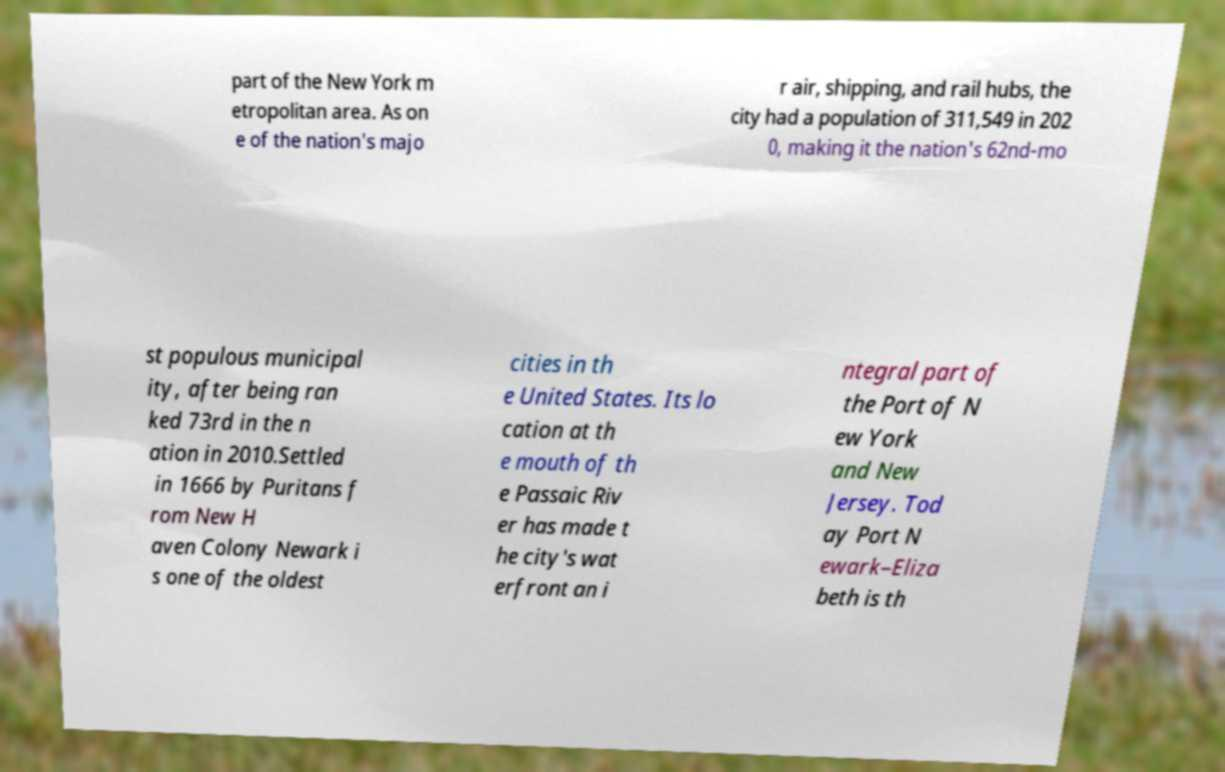For documentation purposes, I need the text within this image transcribed. Could you provide that? part of the New York m etropolitan area. As on e of the nation's majo r air, shipping, and rail hubs, the city had a population of 311,549 in 202 0, making it the nation's 62nd-mo st populous municipal ity, after being ran ked 73rd in the n ation in 2010.Settled in 1666 by Puritans f rom New H aven Colony Newark i s one of the oldest cities in th e United States. Its lo cation at th e mouth of th e Passaic Riv er has made t he city's wat erfront an i ntegral part of the Port of N ew York and New Jersey. Tod ay Port N ewark–Eliza beth is th 